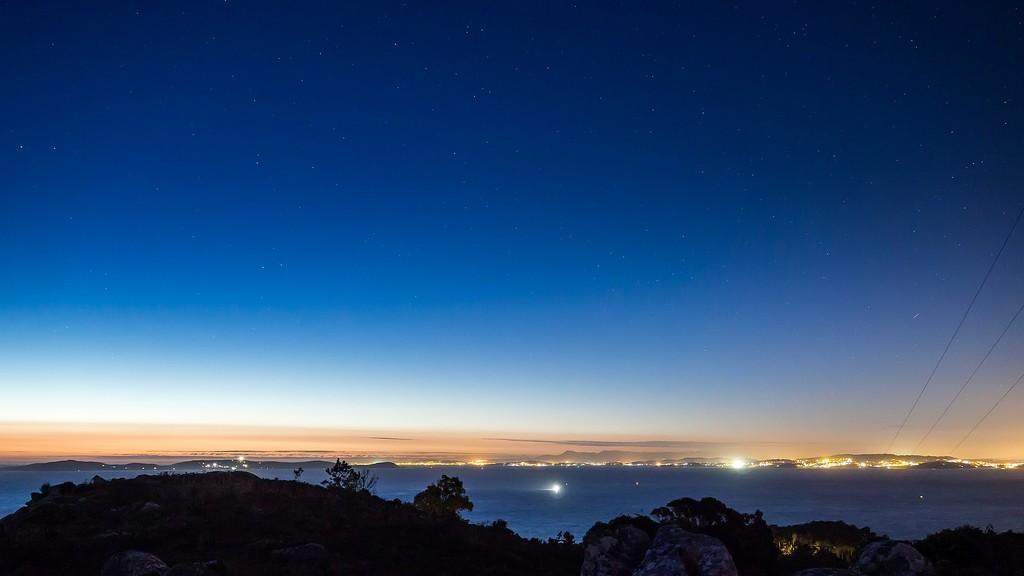How would you summarize this image in a sentence or two? On the bottom we can see the mountain, trees and plants. In the background we can see lights, which is coming from the city. On the left we can see electric wires. At the top we can see sky and stars. 